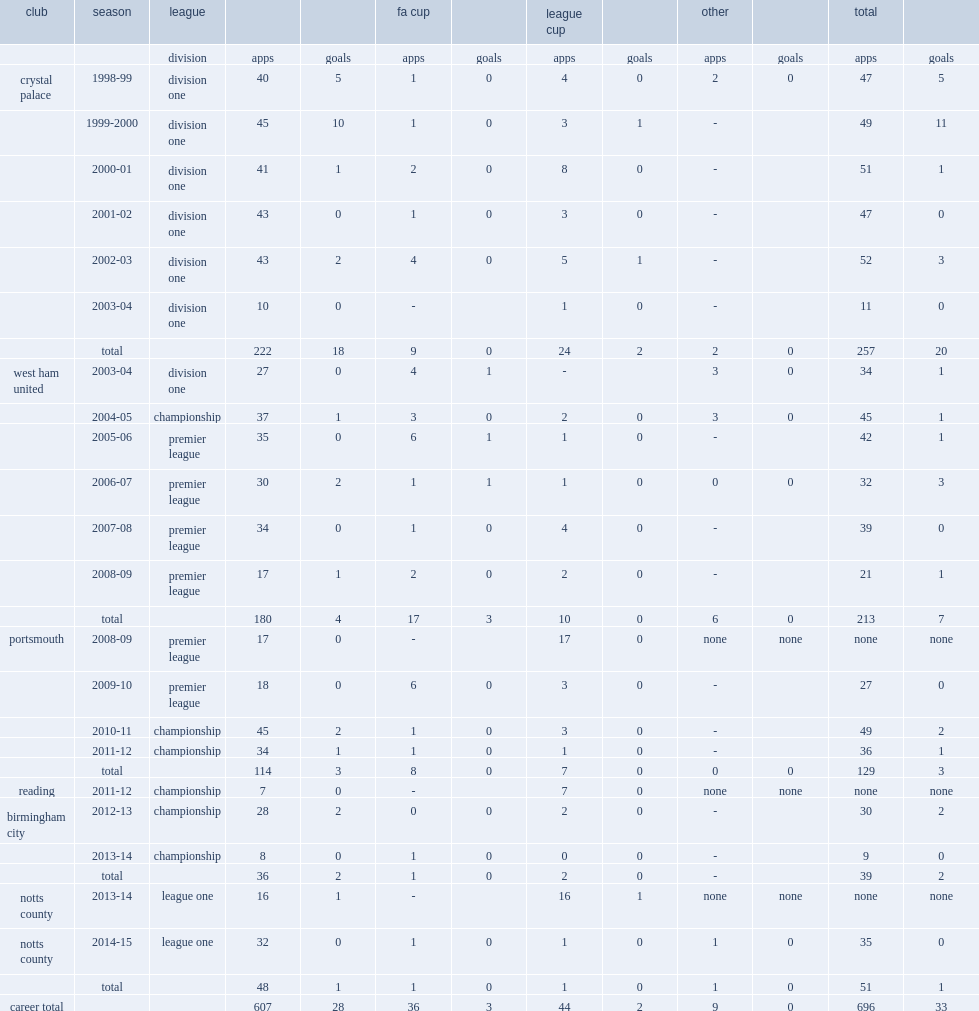Which club did hayden mullins play for in 1999-2000? Crystal palace. 